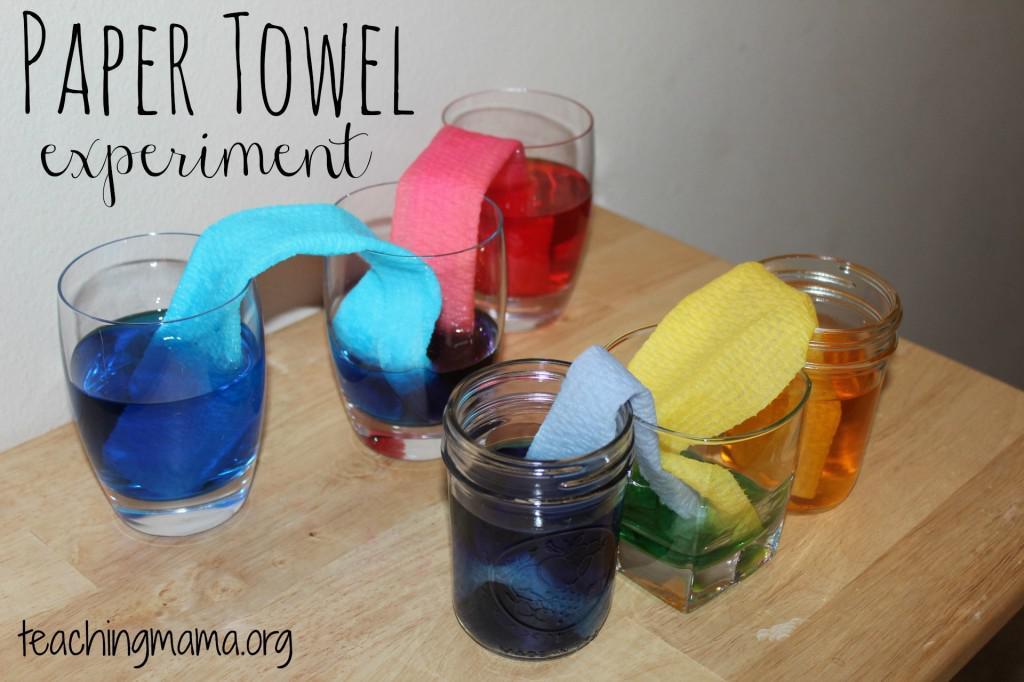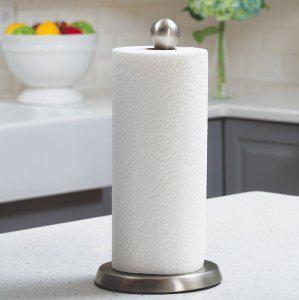The first image is the image on the left, the second image is the image on the right. Given the left and right images, does the statement "One image features a single package of six rolls in two rows of three." hold true? Answer yes or no. No. The first image is the image on the left, the second image is the image on the right. For the images shown, is this caption "There are six rolls of paper towel in the package in the image on the left." true? Answer yes or no. No. 